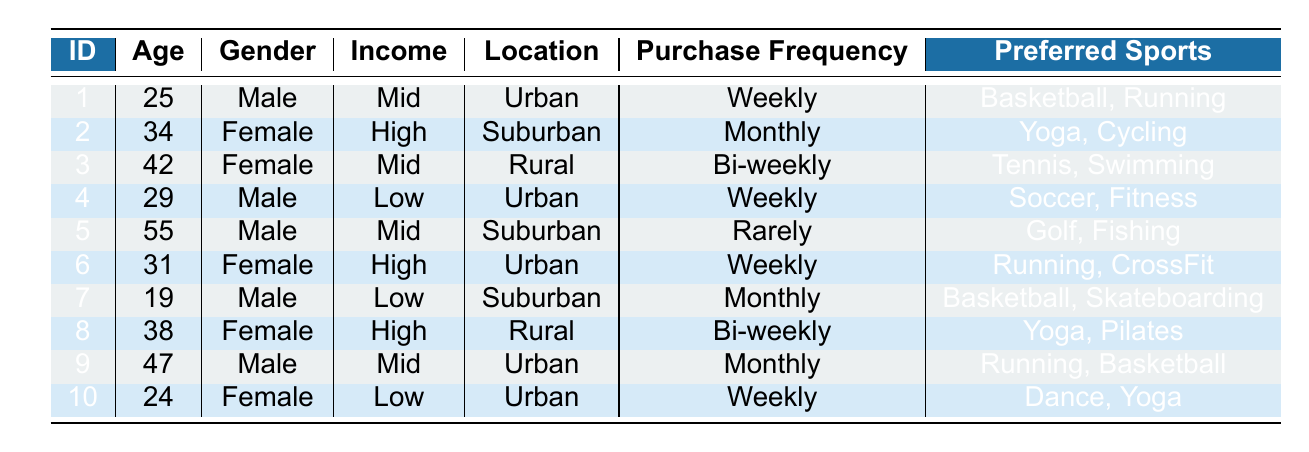What is the purchase frequency of customer ID 3? Customer ID 3 has their purchase frequency listed in the table as "Bi-weekly."
Answer: Bi-weekly How many female customers are there in the table? There are 5 customers identified as female (IDs 2, 3, 6, 8, and 10) within the table.
Answer: 5 Which customer has the highest income level? Customer ID 2 and Customer ID 6 both have their income level listed as "High," making them the highest income customers in the table.
Answer: ID 2 and ID 6 What is the average age of customers who purchase weekly? The ages of customers who purchase weekly are 25 (ID 1), 29 (ID 4), 31 (ID 6), and 24 (ID 10). Adding these ages gives a total of 25 + 29 + 31 + 24 = 109. There are 4 customers, so the average age is 109/4 = 27.25.
Answer: 27.25 Are there any rural customers who purchase monthly? Looking at the table, the only rural customer (ID 3 and ID 8) do not have a purchase frequency of "Monthly." Thus, there are no rural customers with that frequency.
Answer: No What preferred sports do customers with low income enjoy? Customers with low income are ID 4 (Soccer, Fitness), ID 5 (Golf, Fishing), and ID 7 (Basketball, Skateboarding). Their preferred sports combined are Soccer, Fitness, Golf, Fishing, Basketball, and Skateboarding.
Answer: Soccer, Fitness, Golf, Fishing, Basketball, Skateboarding Which location has the most customers? Counting the customer locations, Urban has 4 (IDs 1, 4, 6, and 9), Suburban has 3 (IDs 2, 7, and 5), and Rural has 3 (IDs 3 and 8). Therefore, Urban has the most customers.
Answer: Urban How many customers prefer sports related to fitness? Referring to the table, customers who prefer fitness-related sports include ID 4 (Fitness) and ID 6 (CrossFit). Hence, there are 3 customers, including the ones mentioning running which could also be seen as fitness.
Answer: 3 What is the most common purchase frequency among the customers? The frequency "Weekly" appears for 4 customers (IDs 1, 4, 6, and 10), which is higher compared to other frequencies. Thus, the most common purchase frequency is Weekly.
Answer: Weekly 